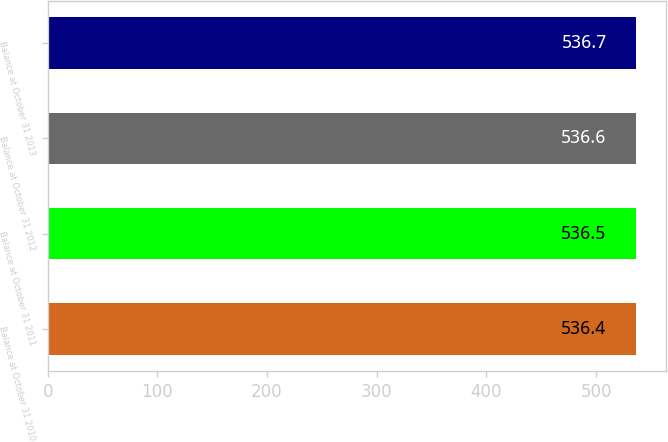<chart> <loc_0><loc_0><loc_500><loc_500><bar_chart><fcel>Balance at October 31 2010<fcel>Balance at October 31 2011<fcel>Balance at October 31 2012<fcel>Balance at October 31 2013<nl><fcel>536.4<fcel>536.5<fcel>536.6<fcel>536.7<nl></chart> 